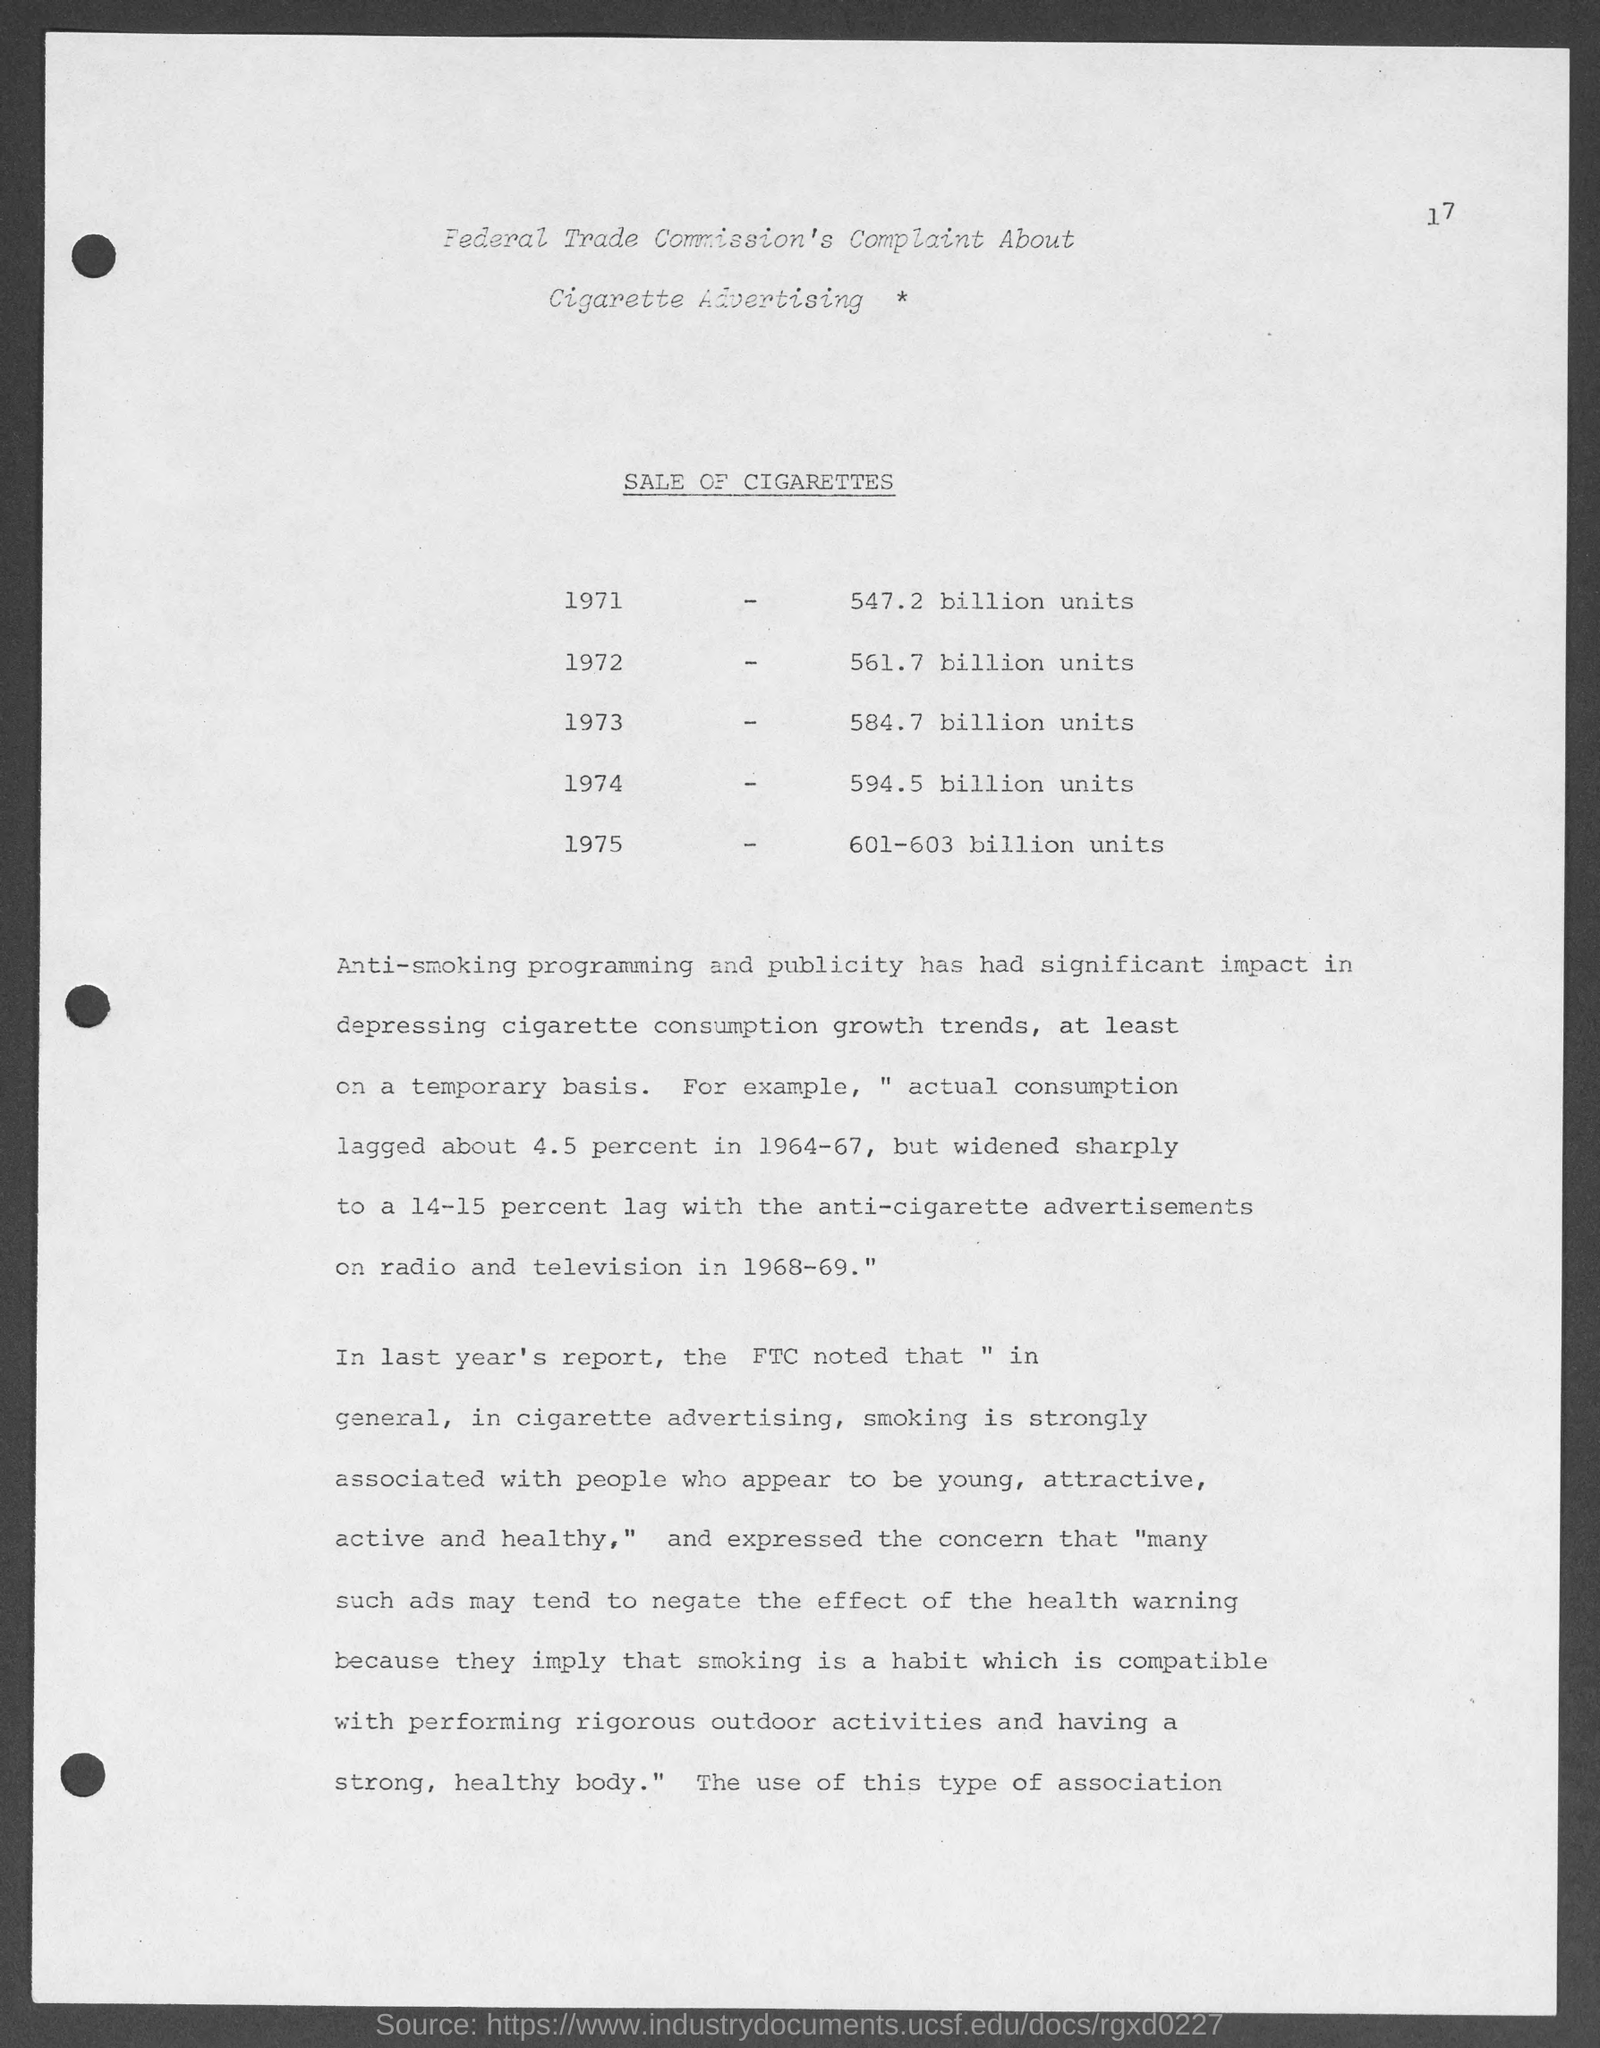Give some essential details in this illustration. In 1974, the sale of cigarettes reached a staggering 594.5 billion units. In the year 1972, the sale of cigarettes reached a significant milestone with a total of 561.7 billion units sold. The sale of cigarettes in the year 1971 was 547.2 billion units. In the year 1975, the sale of cigarettes reached a staggering 601-603 billion units. 